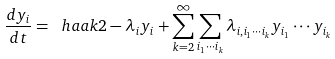Convert formula to latex. <formula><loc_0><loc_0><loc_500><loc_500>\frac { d y _ { i } } { d t } = \ h a a k { 2 - \lambda _ { i } } y _ { i } + \sum _ { k = 2 } ^ { \infty } \sum _ { i _ { 1 } \cdots i _ { k } } \lambda _ { i , i _ { 1 } \cdots i _ { k } } y _ { i _ { 1 } } \cdots y _ { i _ { k } }</formula> 